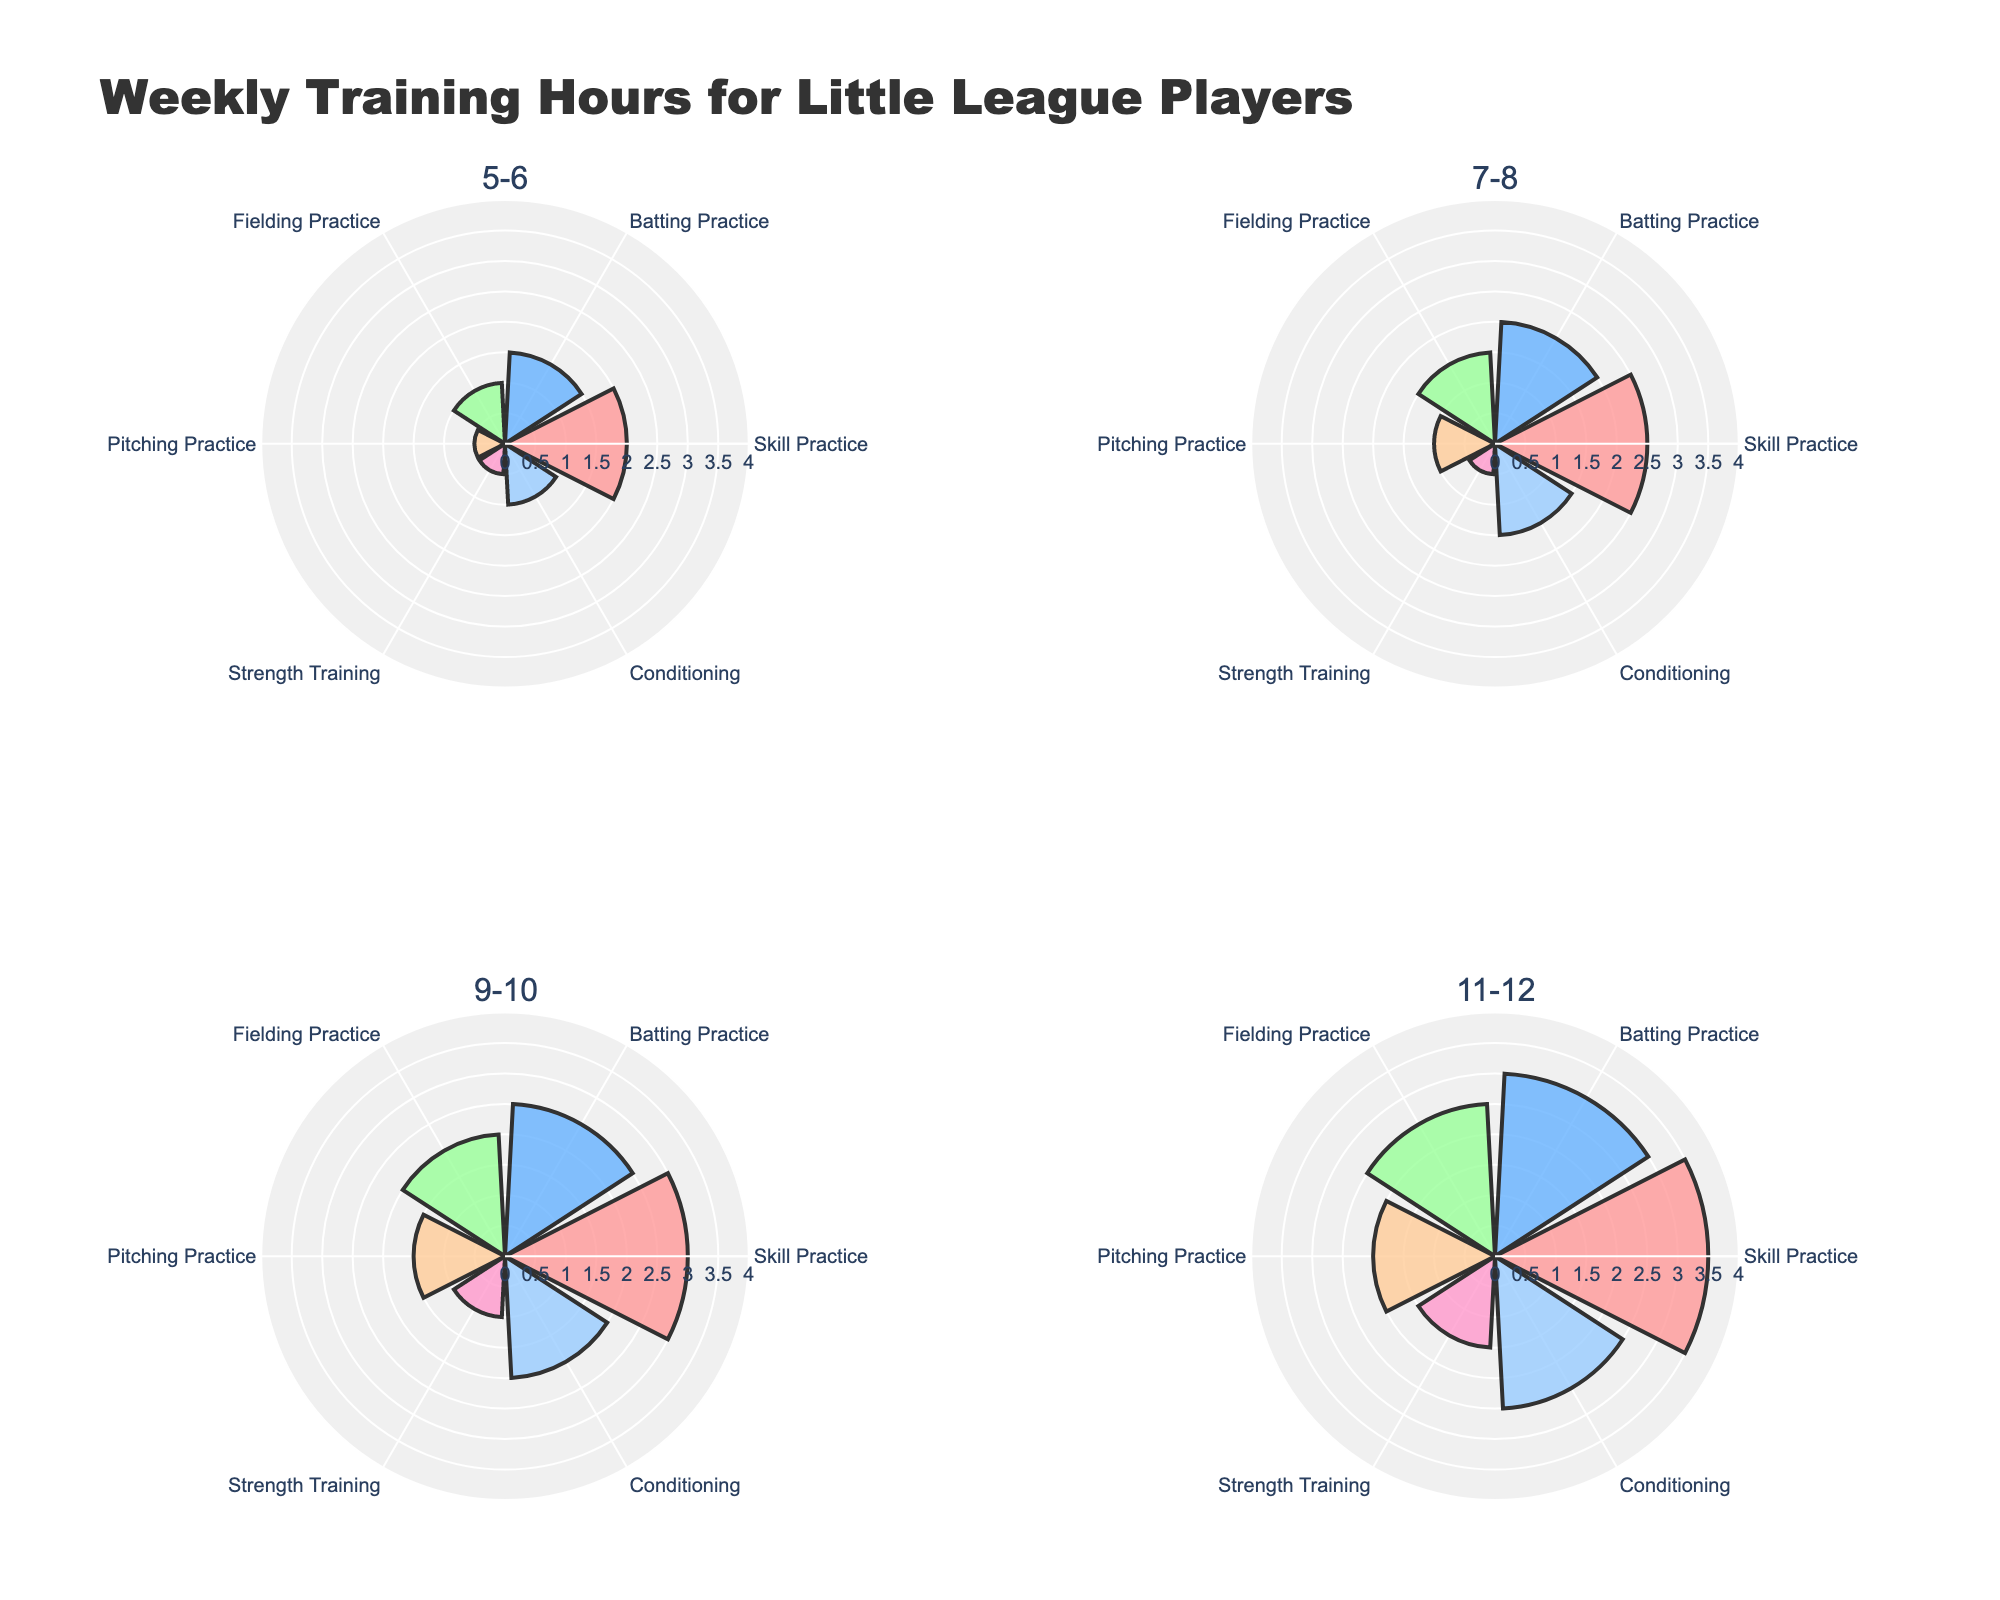What is the total weekly training hours for players aged 9-10? Sum the hours for Skill Practice (3), Batting Practice (2.5), Fielding Practice (2), Pitching Practice (1.5), Strength Training (1), and Conditioning (2): 3 + 2.5 + 2 + 1.5 + 1 + 2 = 12
Answer: 12 Which age group spends the most hours in Strength Training? Compare the Strength Training hours for each age group: 0.5 (5-6), 0.5 (7-8), 1 (9-10), 1.5 (11-12). The age group 11-12 spends the most hours
Answer: 11-12 How much more time do players aged 11-12 spend on Skill Practice compared to players aged 7-8? Skill Practice for 11-12 is 3.5 hours, and for 7-8 is 2.5 hours. The difference is 3.5 - 2.5 = 1 hour
Answer: 1 hour Which practice type has the smallest difference in hours between the youngest (5-6) and the oldest (11-12) age groups? Calculate differences for each type: Skill Practice (3.5-2=1.5), Batting Practice (3-1.5=1.5), Fielding Practice (2.5-1=1.5), Pitching Practice (2-0.5=1.5), Strength Training (1.5-0.5=1), Conditioning (2.5-1=1.5). Strength Training has the smallest difference (1 hour)
Answer: Strength Training In which age group do players spend the most hours on Batting Practice? Compare Batting Practice hours: 1.5 (5-6), 2 (7-8), 2.5 (9-10), 3 (11-12). The age group 11-12 spends the most hours
Answer: 11-12 Which practice type shows a consistent increase in hours as the age group increases? Check each practice type: 
Skill Practice: 2, 2.5, 3, 3.5 (increasing)
Batting Practice: 1.5, 2, 2.5, 3 (increasing)
Fielding Practice: 1, 1.5, 2, 2.5 (increasing)
Pitching Practice: 0.5, 1, 1.5, 2 (increasing)
Strength Training: 0.5, 0.5, 1, 1.5 (increasing)
Conditioning: 1, 1.5, 2, 2.5 (increasing)
All practice types increase consistently
Answer: All practice types What is the average time spent on Conditioning across all age groups? Add Conditioning hours for all groups: 1 (5-6), 1.5 (7-8), 2 (9-10), 2.5 (11-12). The total is 1 + 1.5 + 2 + 2.5 = 7. Divide by number of age groups (4): 7/4 = 1.75
Answer: 1.75 hours 